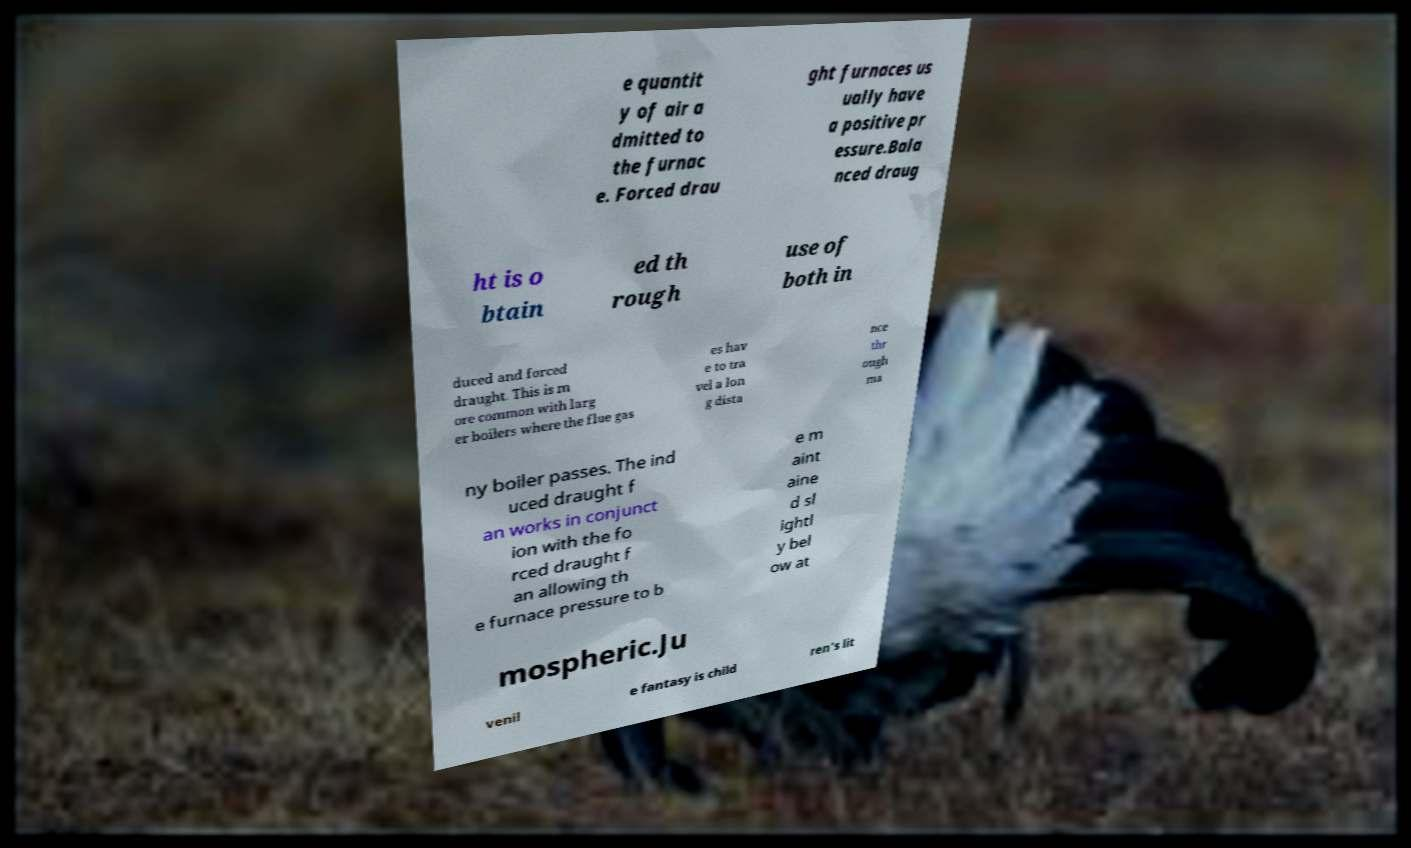For documentation purposes, I need the text within this image transcribed. Could you provide that? e quantit y of air a dmitted to the furnac e. Forced drau ght furnaces us ually have a positive pr essure.Bala nced draug ht is o btain ed th rough use of both in duced and forced draught. This is m ore common with larg er boilers where the flue gas es hav e to tra vel a lon g dista nce thr ough ma ny boiler passes. The ind uced draught f an works in conjunct ion with the fo rced draught f an allowing th e furnace pressure to b e m aint aine d sl ightl y bel ow at mospheric.Ju venil e fantasy is child ren's lit 